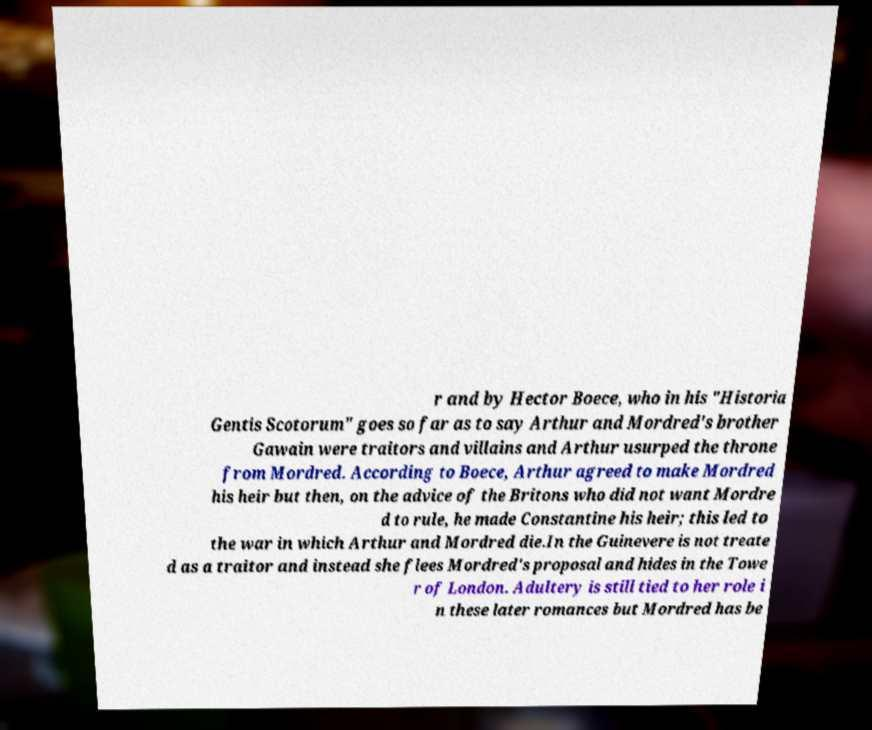Can you accurately transcribe the text from the provided image for me? r and by Hector Boece, who in his "Historia Gentis Scotorum" goes so far as to say Arthur and Mordred's brother Gawain were traitors and villains and Arthur usurped the throne from Mordred. According to Boece, Arthur agreed to make Mordred his heir but then, on the advice of the Britons who did not want Mordre d to rule, he made Constantine his heir; this led to the war in which Arthur and Mordred die.In the Guinevere is not treate d as a traitor and instead she flees Mordred's proposal and hides in the Towe r of London. Adultery is still tied to her role i n these later romances but Mordred has be 